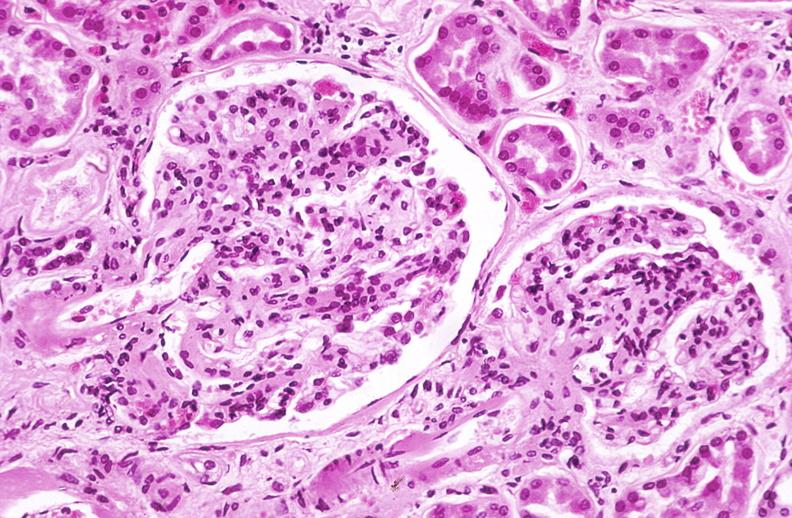what does this image show?
Answer the question using a single word or phrase. Kidney glomerulus 